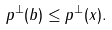<formula> <loc_0><loc_0><loc_500><loc_500>p ^ { \bot } ( b ) \leq p ^ { \bot } ( x ) .</formula> 